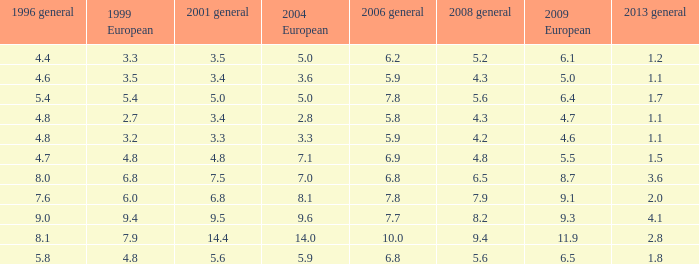What is the minimum amount for 2004 european when 1999 european is None. 